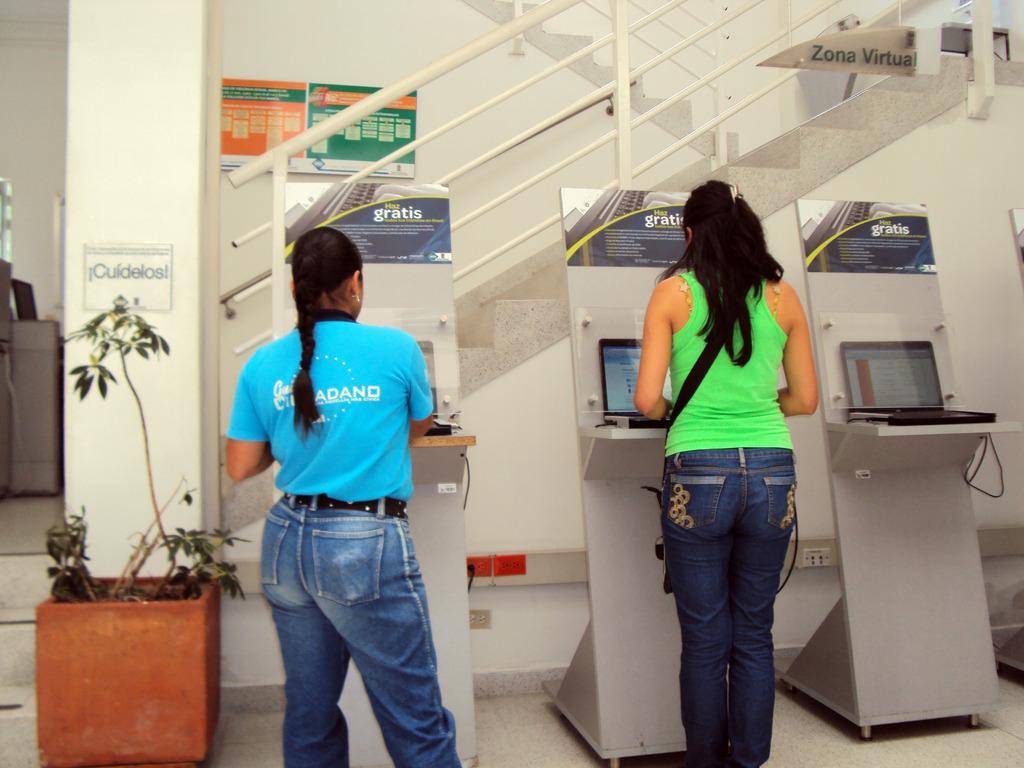How would you summarize this image in a sentence or two? In the center of the image two ladies are standing and operating the laptop. In the background of the image we can see the stands, laptops, pillar, stairs, pot, plant, boards, wall are there. On the left side of the image we can see a machine is there. At the bottom of the image floor is there. 